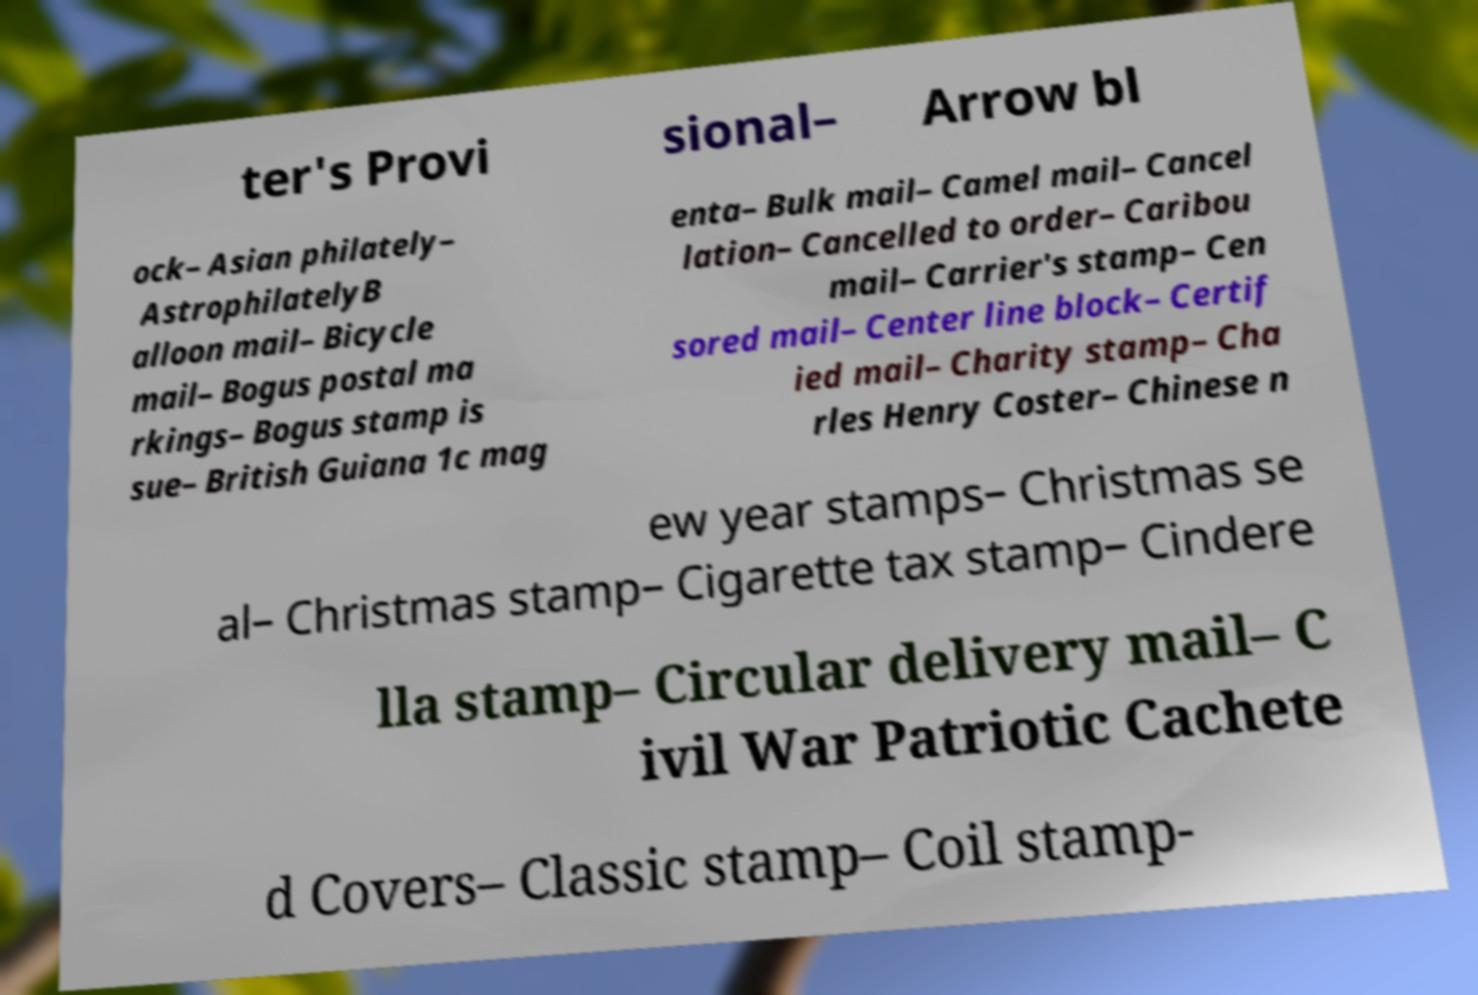Can you accurately transcribe the text from the provided image for me? ter's Provi sional– Arrow bl ock– Asian philately– AstrophilatelyB alloon mail– Bicycle mail– Bogus postal ma rkings– Bogus stamp is sue– British Guiana 1c mag enta– Bulk mail– Camel mail– Cancel lation– Cancelled to order– Caribou mail– Carrier's stamp– Cen sored mail– Center line block– Certif ied mail– Charity stamp– Cha rles Henry Coster– Chinese n ew year stamps– Christmas se al– Christmas stamp– Cigarette tax stamp– Cindere lla stamp– Circular delivery mail– C ivil War Patriotic Cachete d Covers– Classic stamp– Coil stamp- 